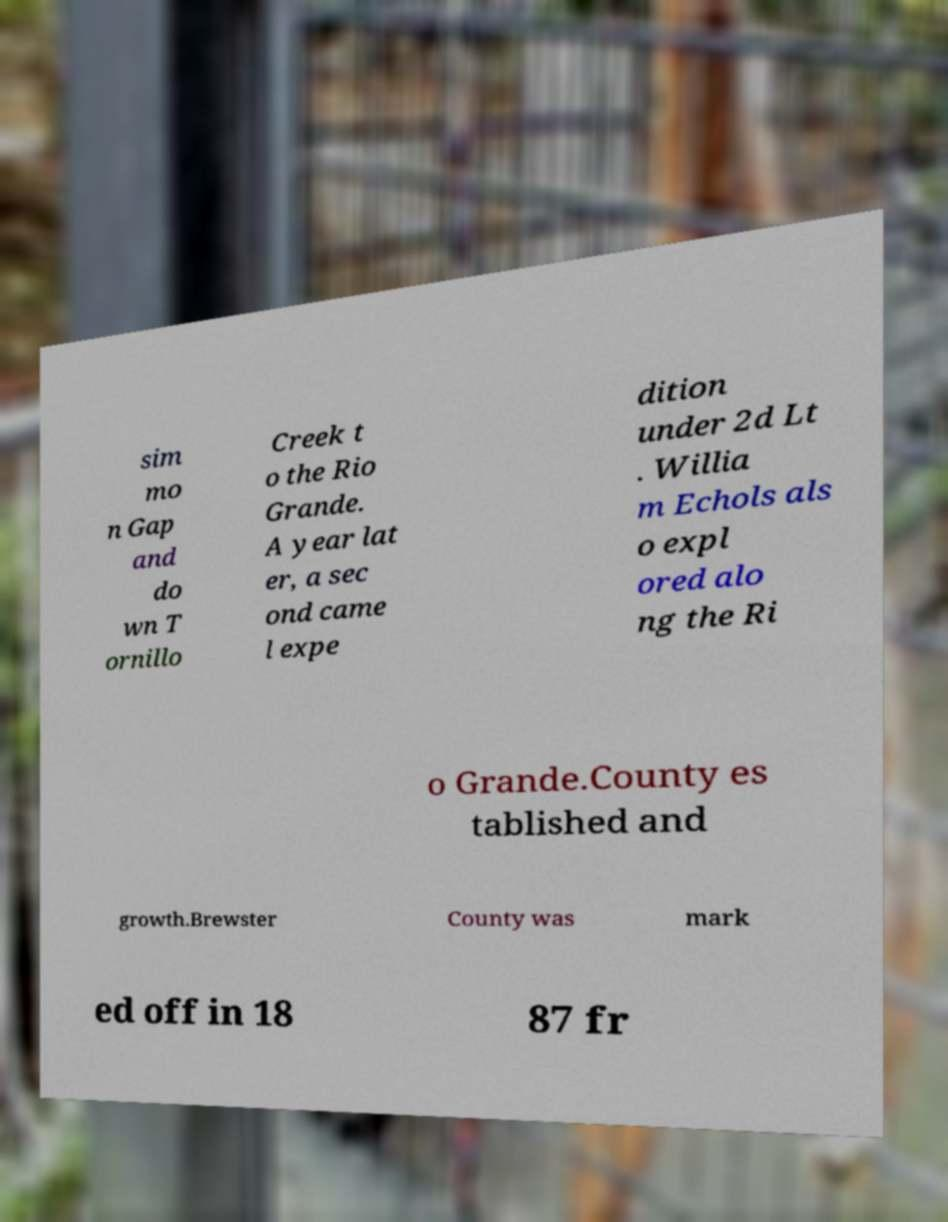What messages or text are displayed in this image? I need them in a readable, typed format. sim mo n Gap and do wn T ornillo Creek t o the Rio Grande. A year lat er, a sec ond came l expe dition under 2d Lt . Willia m Echols als o expl ored alo ng the Ri o Grande.County es tablished and growth.Brewster County was mark ed off in 18 87 fr 